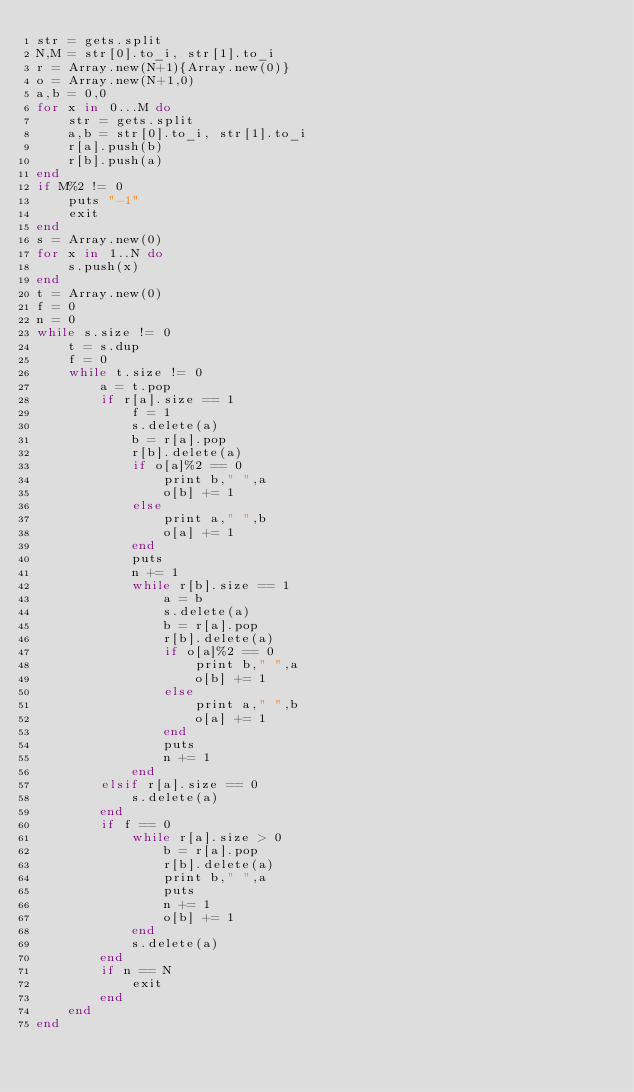Convert code to text. <code><loc_0><loc_0><loc_500><loc_500><_Ruby_>str = gets.split
N,M = str[0].to_i, str[1].to_i
r = Array.new(N+1){Array.new(0)}
o = Array.new(N+1,0)
a,b = 0,0
for x in 0...M do
    str = gets.split
    a,b = str[0].to_i, str[1].to_i
    r[a].push(b)
    r[b].push(a)
end
if M%2 != 0
    puts "-1"
    exit
end
s = Array.new(0)
for x in 1..N do
    s.push(x)
end
t = Array.new(0)
f = 0
n = 0
while s.size != 0
    t = s.dup
    f = 0
    while t.size != 0
        a = t.pop
        if r[a].size == 1
            f = 1
            s.delete(a)
            b = r[a].pop
            r[b].delete(a)
            if o[a]%2 == 0
                print b," ",a
                o[b] += 1
            else
                print a," ",b
                o[a] += 1
            end
            puts
            n += 1
            while r[b].size == 1
                a = b
                s.delete(a)
                b = r[a].pop
                r[b].delete(a)
                if o[a]%2 == 0
                    print b," ",a
                    o[b] += 1
                else
                    print a," ",b
                    o[a] += 1
                end
                puts
                n += 1
            end
        elsif r[a].size == 0
            s.delete(a)
        end
        if f == 0
            while r[a].size > 0
                b = r[a].pop
                r[b].delete(a)
                print b," ",a
                puts
                n += 1
                o[b] += 1
            end
            s.delete(a)
        end
        if n == N
            exit
        end
    end
end</code> 